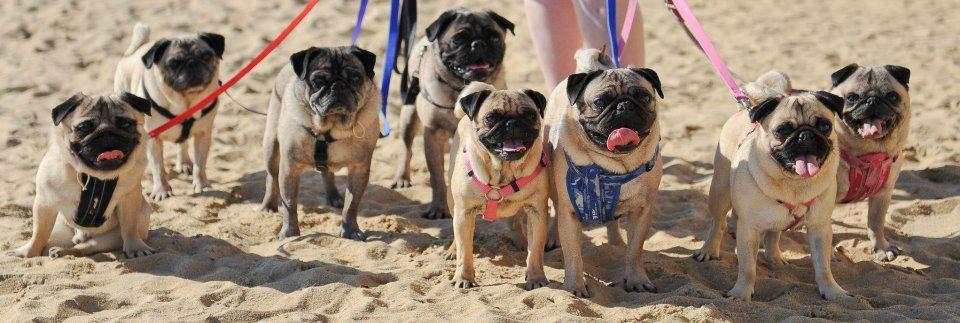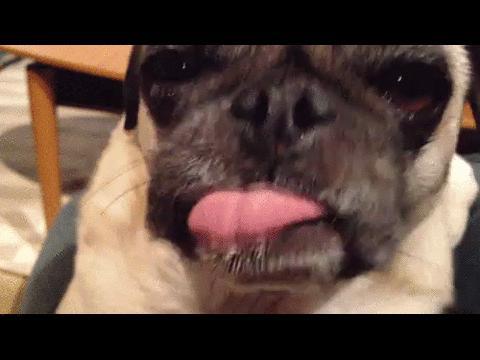The first image is the image on the left, the second image is the image on the right. Analyze the images presented: Is the assertion "All of the dogs are the same color and none of them are tied on a leash." valid? Answer yes or no. No. The first image is the image on the left, the second image is the image on the right. For the images shown, is this caption "There are more pug dogs in the right image than in the left." true? Answer yes or no. No. 